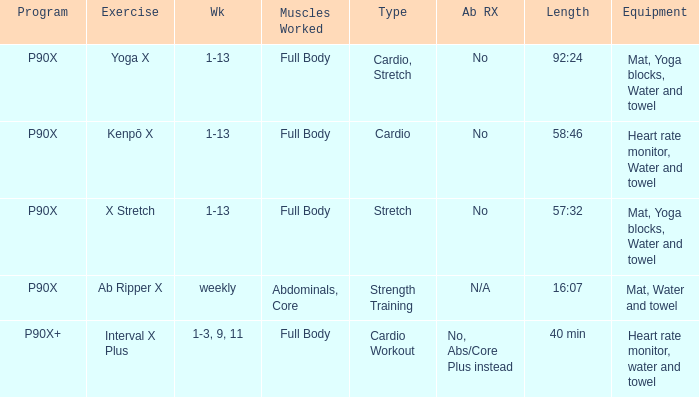How many types are cardio? 1.0. 